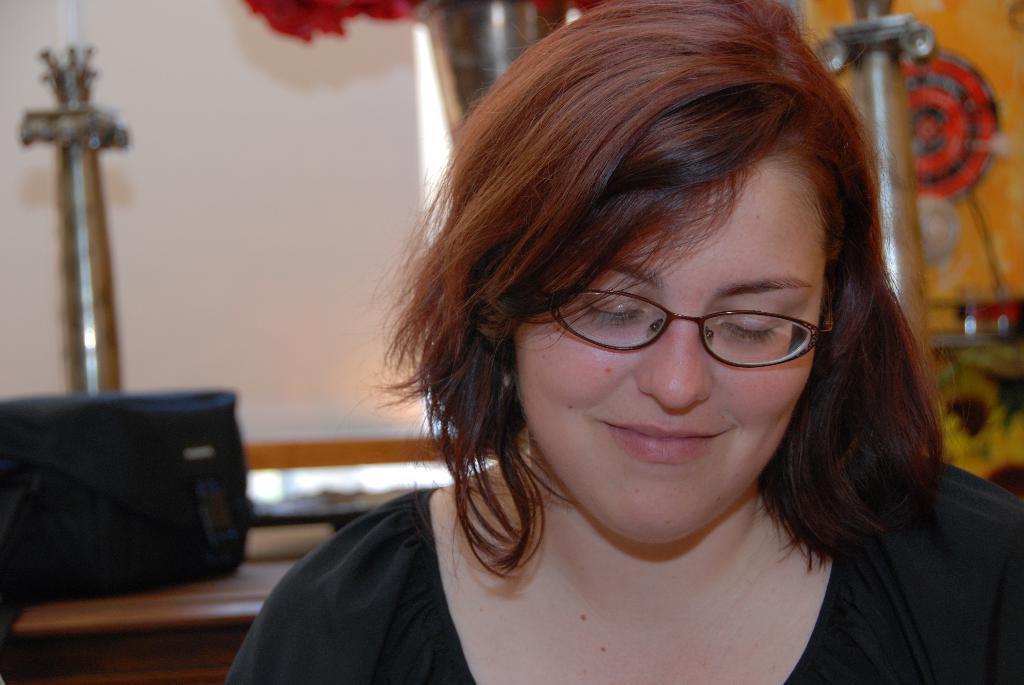Can you describe this image briefly? In this image, we can see a person wearing clothes and spectacles. In the background, image is blurred. 